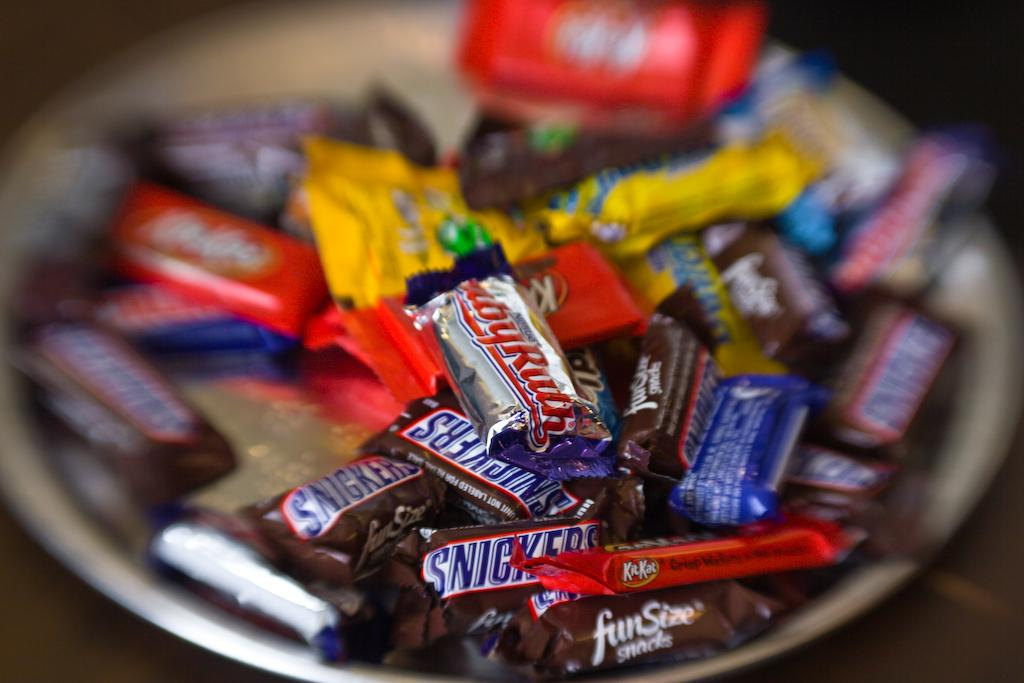What type of food is present in the image? There are chocolates in the image. How are the chocolates arranged in the image? The chocolates are kept in a plate. Can you describe the appearance of some of the chocolates in the image? Some of the chocolates are blurred in the image. What type of pollution can be seen in the image? There is no pollution present in the image; it features chocolates in a plate. Can you tell me a joke that is related to the chocolates in the image? There is no joke present in the image, as it only contains chocolates in a plate. 